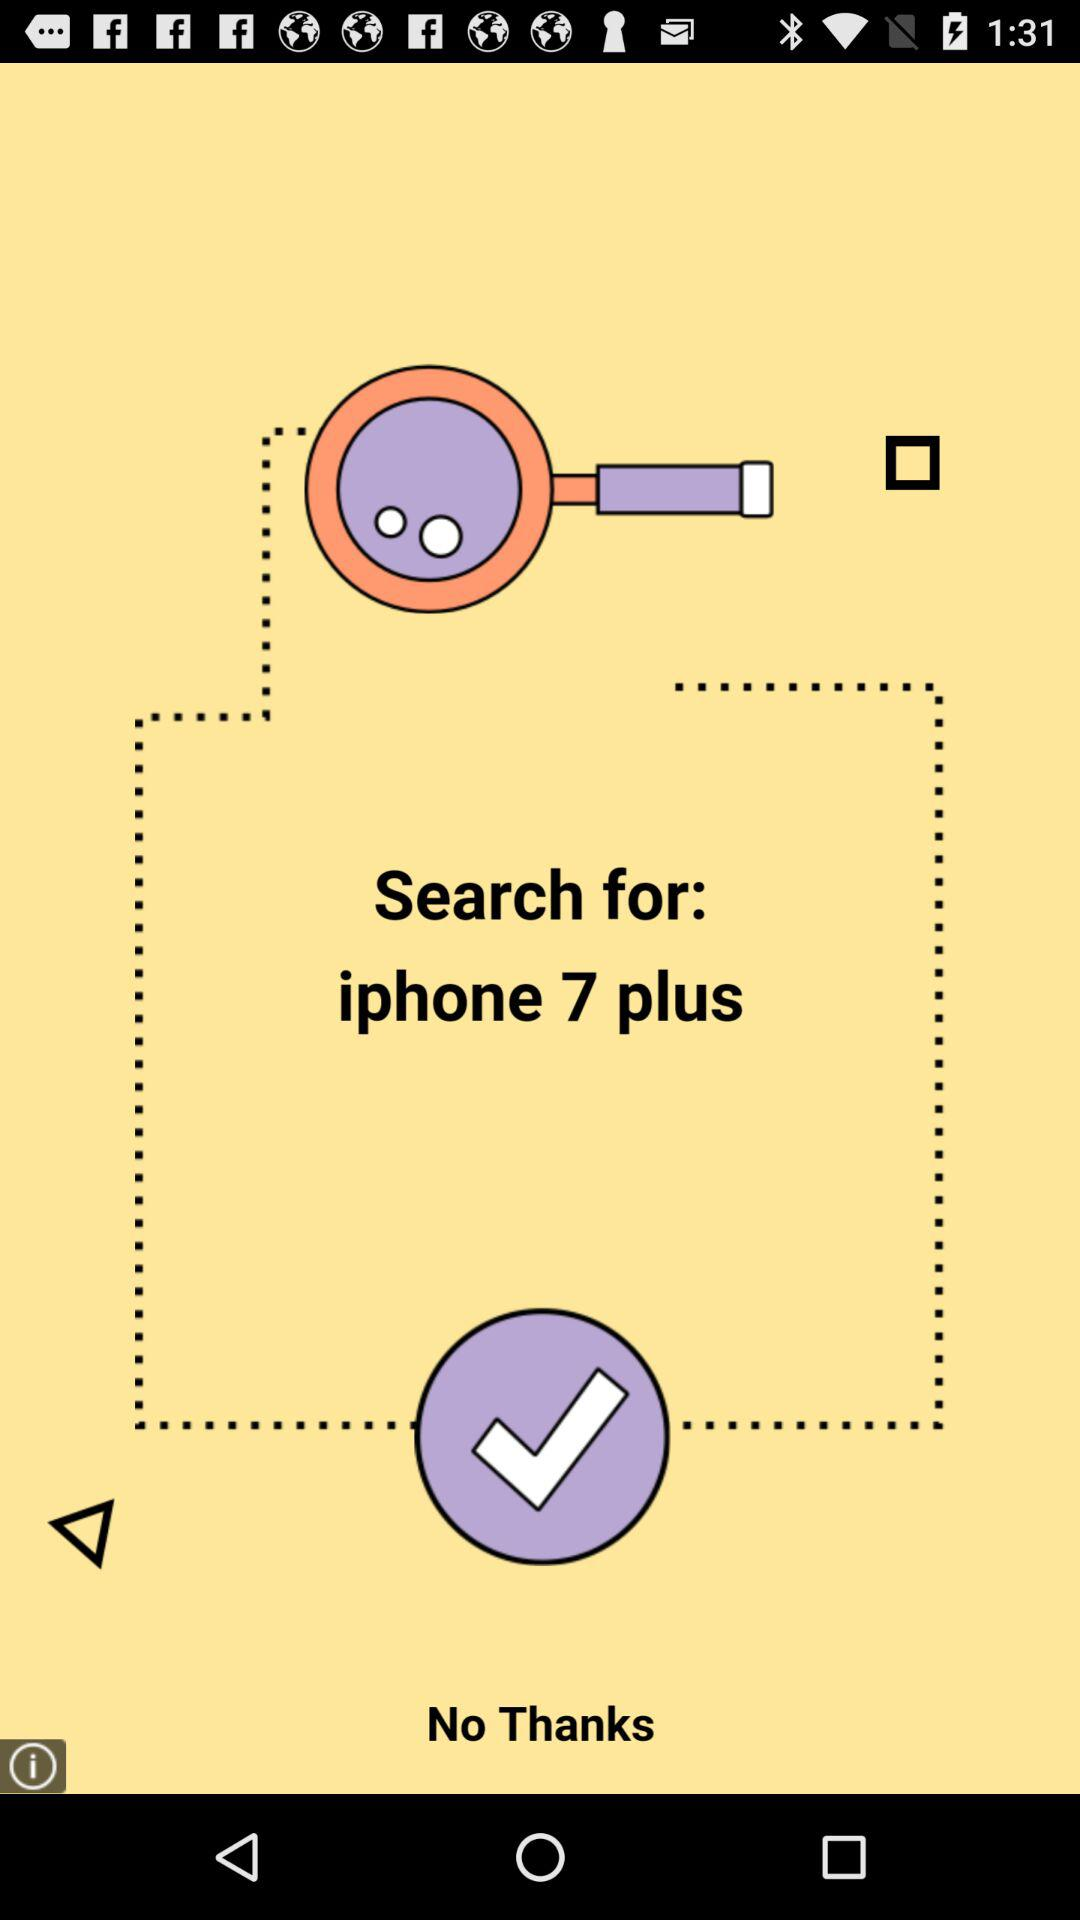What is the name of the application?
When the provided information is insufficient, respond with <no answer>. <no answer> 